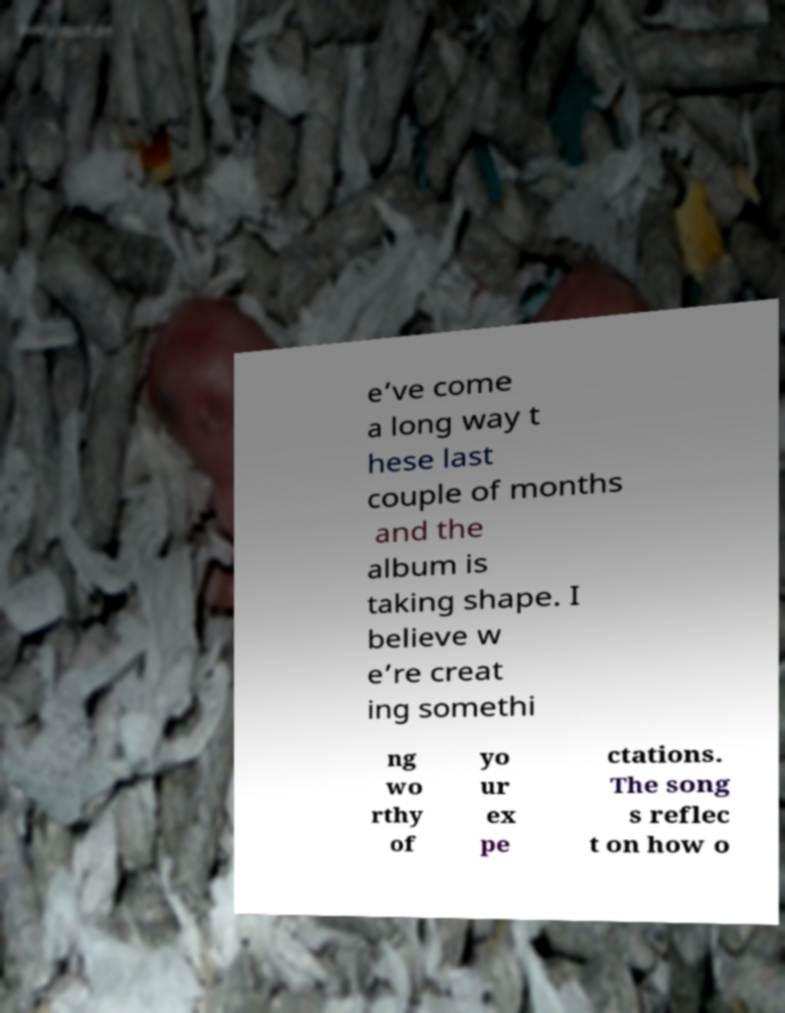For documentation purposes, I need the text within this image transcribed. Could you provide that? e’ve come a long way t hese last couple of months and the album is taking shape. I believe w e’re creat ing somethi ng wo rthy of yo ur ex pe ctations. The song s reflec t on how o 